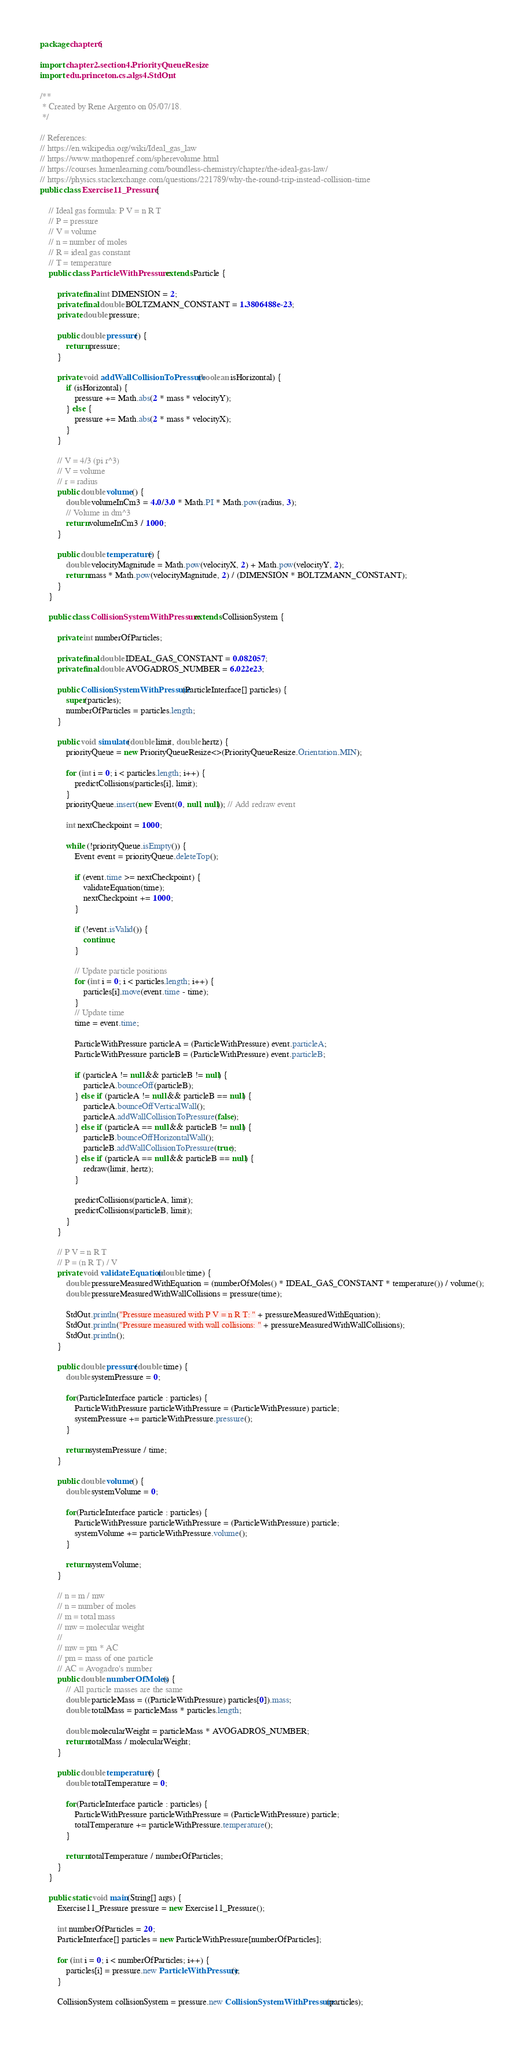Convert code to text. <code><loc_0><loc_0><loc_500><loc_500><_Java_>package chapter6;

import chapter2.section4.PriorityQueueResize;
import edu.princeton.cs.algs4.StdOut;

/**
 * Created by Rene Argento on 05/07/18.
 */

// References:
// https://en.wikipedia.org/wiki/Ideal_gas_law
// https://www.mathopenref.com/spherevolume.html
// https://courses.lumenlearning.com/boundless-chemistry/chapter/the-ideal-gas-law/
// https://physics.stackexchange.com/questions/221789/why-the-round-trip-instead-collision-time
public class Exercise11_Pressure {

    // Ideal gas formula: P V = n R T
    // P = pressure
    // V = volume
    // n = number of moles
    // R = ideal gas constant
    // T = temperature
    public class ParticleWithPressure extends Particle {

        private final int DIMENSION = 2;
        private final double BOLTZMANN_CONSTANT = 1.3806488e-23;
        private double pressure;

        public double pressure() {
            return pressure;
        }

        private void addWallCollisionToPressure(boolean isHorizontal) {
            if (isHorizontal) {
                pressure += Math.abs(2 * mass * velocityY);
            } else {
                pressure += Math.abs(2 * mass * velocityX);
            }
        }

        // V = 4/3 (pi r^3)
        // V = volume
        // r = radius
        public double volume() {
            double volumeInCm3 = 4.0/3.0 * Math.PI * Math.pow(radius, 3);
            // Volume in dm^3
            return volumeInCm3 / 1000;
        }

        public double temperature() {
            double velocityMagnitude = Math.pow(velocityX, 2) + Math.pow(velocityY, 2);
            return mass * Math.pow(velocityMagnitude, 2) / (DIMENSION * BOLTZMANN_CONSTANT);
        }
    }

    public class CollisionSystemWithPressure extends CollisionSystem {

        private int numberOfParticles;

        private final double IDEAL_GAS_CONSTANT = 0.082057;
        private final double AVOGADROS_NUMBER = 6.022e23;

        public CollisionSystemWithPressure(ParticleInterface[] particles) {
            super(particles);
            numberOfParticles = particles.length;
        }

        public void simulate(double limit, double hertz) {
            priorityQueue = new PriorityQueueResize<>(PriorityQueueResize.Orientation.MIN);

            for (int i = 0; i < particles.length; i++) {
                predictCollisions(particles[i], limit);
            }
            priorityQueue.insert(new Event(0, null, null)); // Add redraw event

            int nextCheckpoint = 1000;

            while (!priorityQueue.isEmpty()) {
                Event event = priorityQueue.deleteTop();

                if (event.time >= nextCheckpoint) {
                    validateEquation(time);
                    nextCheckpoint += 1000;
                }

                if (!event.isValid()) {
                    continue;
                }

                // Update particle positions
                for (int i = 0; i < particles.length; i++) {
                    particles[i].move(event.time - time);
                }
                // Update time
                time = event.time;

                ParticleWithPressure particleA = (ParticleWithPressure) event.particleA;
                ParticleWithPressure particleB = (ParticleWithPressure) event.particleB;

                if (particleA != null && particleB != null) {
                    particleA.bounceOff(particleB);
                } else if (particleA != null && particleB == null) {
                    particleA.bounceOffVerticalWall();
                    particleA.addWallCollisionToPressure(false);
                } else if (particleA == null && particleB != null) {
                    particleB.bounceOffHorizontalWall();
                    particleB.addWallCollisionToPressure(true);
                } else if (particleA == null && particleB == null) {
                    redraw(limit, hertz);
                }

                predictCollisions(particleA, limit);
                predictCollisions(particleB, limit);
            }
        }

        // P V = n R T
        // P = (n R T) / V
        private void validateEquation(double time) {
            double pressureMeasuredWithEquation = (numberOfMoles() * IDEAL_GAS_CONSTANT * temperature()) / volume();
            double pressureMeasuredWithWallCollisions = pressure(time);

            StdOut.println("Pressure measured with P V = n R T: " + pressureMeasuredWithEquation);
            StdOut.println("Pressure measured with wall collisions: " + pressureMeasuredWithWallCollisions);
            StdOut.println();
        }

        public double pressure(double time) {
            double systemPressure = 0;

            for(ParticleInterface particle : particles) {
                ParticleWithPressure particleWithPressure = (ParticleWithPressure) particle;
                systemPressure += particleWithPressure.pressure();
            }

            return systemPressure / time;
        }

        public double volume() {
            double systemVolume = 0;

            for(ParticleInterface particle : particles) {
                ParticleWithPressure particleWithPressure = (ParticleWithPressure) particle;
                systemVolume += particleWithPressure.volume();
            }

            return systemVolume;
        }

        // n = m / mw
        // n = number of moles
        // m = total mass
        // mw = molecular weight
        //
        // mw = pm * AC
        // pm = mass of one particle
        // AC = Avogadro's number
        public double numberOfMoles() {
            // All particle masses are the same
            double particleMass = ((ParticleWithPressure) particles[0]).mass;
            double totalMass = particleMass * particles.length;

            double molecularWeight = particleMass * AVOGADROS_NUMBER;
            return totalMass / molecularWeight;
        }

        public double temperature() {
            double totalTemperature = 0;

            for(ParticleInterface particle : particles) {
                ParticleWithPressure particleWithPressure = (ParticleWithPressure) particle;
                totalTemperature += particleWithPressure.temperature();
            }

            return totalTemperature / numberOfParticles;
        }
    }

    public static void main(String[] args) {
        Exercise11_Pressure pressure = new Exercise11_Pressure();

        int numberOfParticles = 20;
        ParticleInterface[] particles = new ParticleWithPressure[numberOfParticles];

        for (int i = 0; i < numberOfParticles; i++) {
            particles[i] = pressure.new ParticleWithPressure();
        }

        CollisionSystem collisionSystem = pressure.new CollisionSystemWithPressure(particles);</code> 